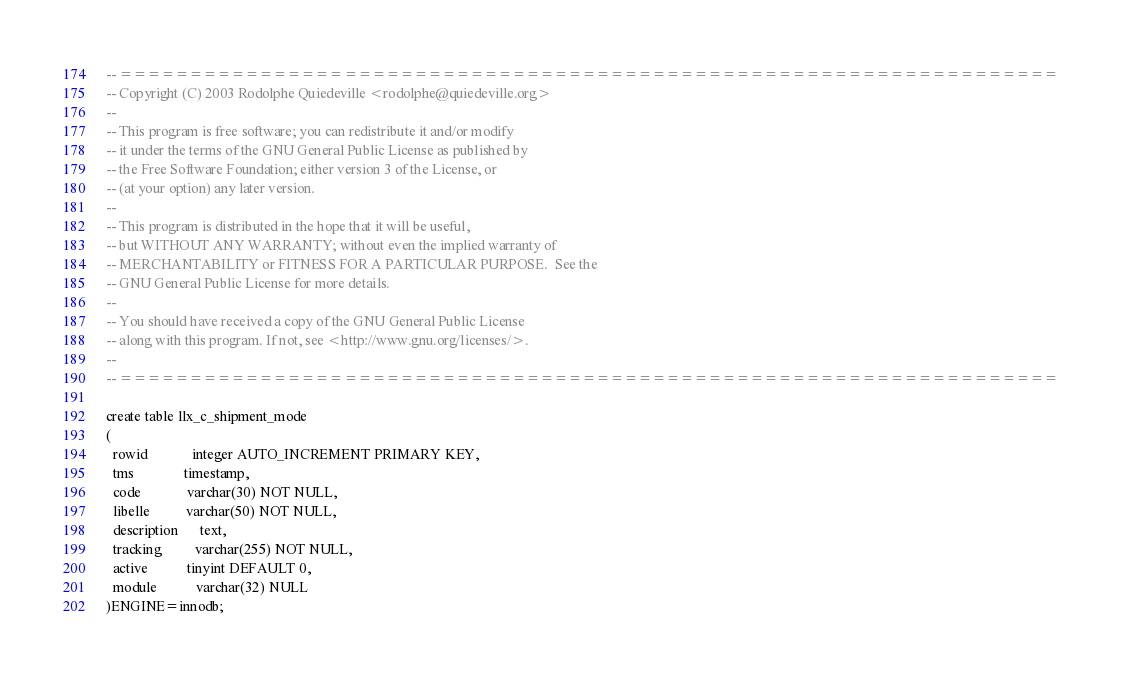<code> <loc_0><loc_0><loc_500><loc_500><_SQL_>-- ===================================================================
-- Copyright (C) 2003 Rodolphe Quiedeville <rodolphe@quiedeville.org>
--
-- This program is free software; you can redistribute it and/or modify
-- it under the terms of the GNU General Public License as published by
-- the Free Software Foundation; either version 3 of the License, or
-- (at your option) any later version.
--
-- This program is distributed in the hope that it will be useful,
-- but WITHOUT ANY WARRANTY; without even the implied warranty of
-- MERCHANTABILITY or FITNESS FOR A PARTICULAR PURPOSE.  See the
-- GNU General Public License for more details.
--
-- You should have received a copy of the GNU General Public License
-- along with this program. If not, see <http://www.gnu.org/licenses/>.
--
-- ===================================================================

create table llx_c_shipment_mode
(
  rowid            integer AUTO_INCREMENT PRIMARY KEY,
  tms              timestamp,
  code             varchar(30) NOT NULL,
  libelle          varchar(50) NOT NULL,
  description      text,
  tracking         varchar(255) NOT NULL,
  active           tinyint DEFAULT 0,
  module           varchar(32) NULL
)ENGINE=innodb;
</code> 